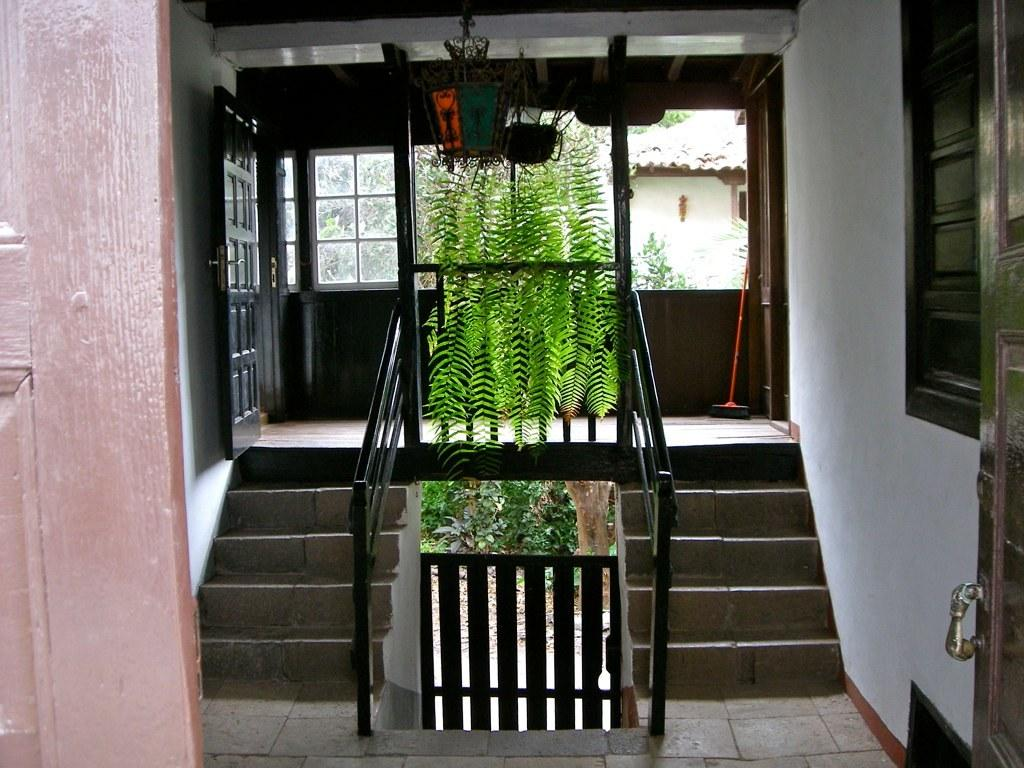What type of architectural feature can be seen in the image? There are doors in the image. What other elements are present in the image besides doors? There are plants, stairs on the left side, stairs on the right side, and a house in the background. How many sets of stairs are visible in the image? There are two sets of stairs visible in the image, one on the left side and one on the right side. What can be seen in the background of the image? There is a house in the background of the image. What type of bread is being used to calculate the temperature in the image? There is no bread or temperature measurement present in the image. 